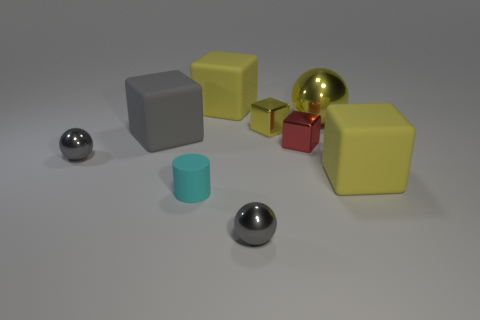Subtract all yellow cubes. How many were subtracted if there are1yellow cubes left? 2 Subtract all green cylinders. How many yellow cubes are left? 3 Subtract all gray metal spheres. How many spheres are left? 1 Subtract all gray blocks. How many blocks are left? 4 Subtract all cyan blocks. Subtract all green cylinders. How many blocks are left? 5 Add 1 small red balls. How many objects exist? 10 Subtract all balls. How many objects are left? 6 Add 8 yellow metal spheres. How many yellow metal spheres exist? 9 Subtract 0 purple cylinders. How many objects are left? 9 Subtract all small red blocks. Subtract all purple shiny blocks. How many objects are left? 8 